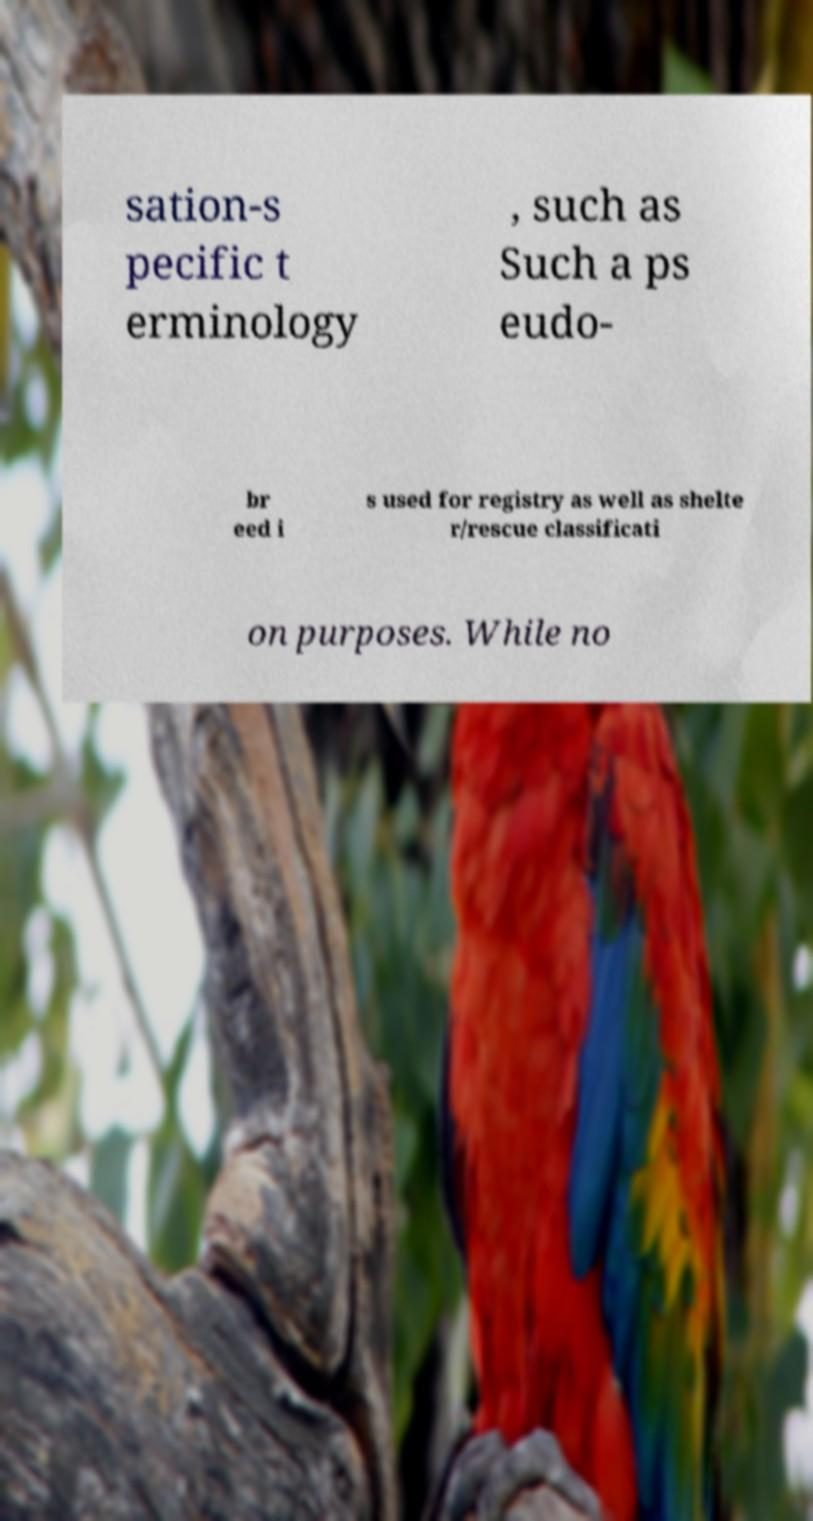Please read and relay the text visible in this image. What does it say? sation-s pecific t erminology , such as Such a ps eudo- br eed i s used for registry as well as shelte r/rescue classificati on purposes. While no 